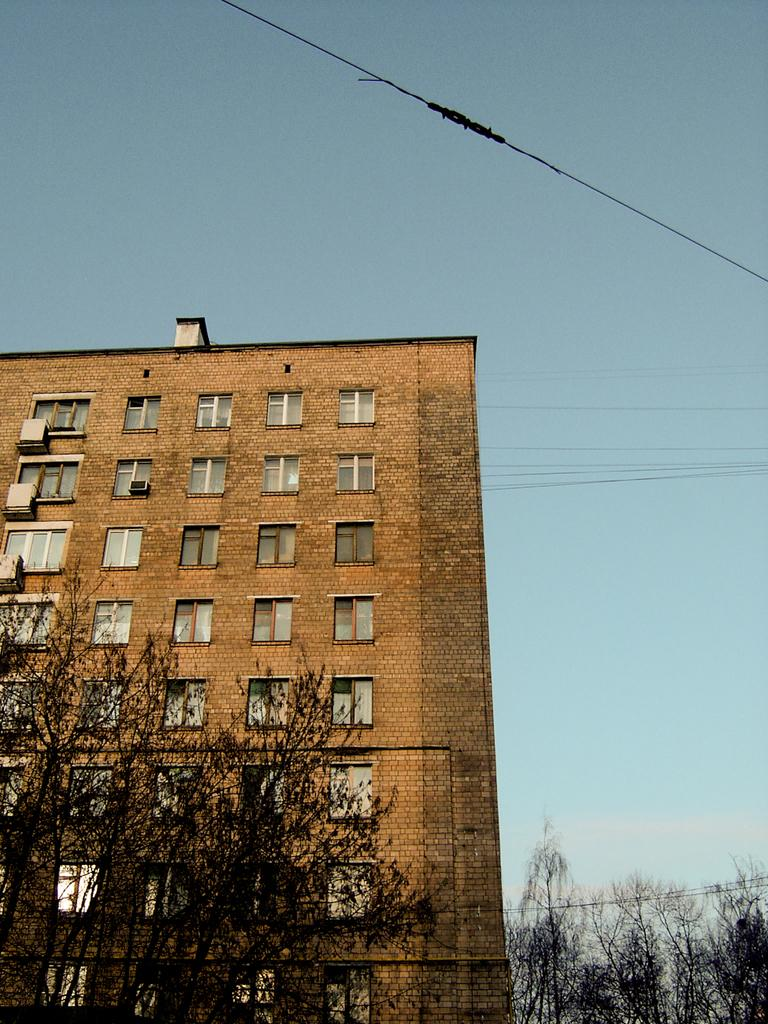What type of structure is visible in the image? There is a building in the image. Can you describe the building's appearance? The building has many windows. What else can be seen in the image besides the building? There are many trees in the image. How would you describe the weather based on the image? The sky is clear and blue in the image, suggesting good weather. What type of neck accessory is the building wearing in the image? There is no neck accessory present in the image, as the subject is a building and not a person or animal. --- 